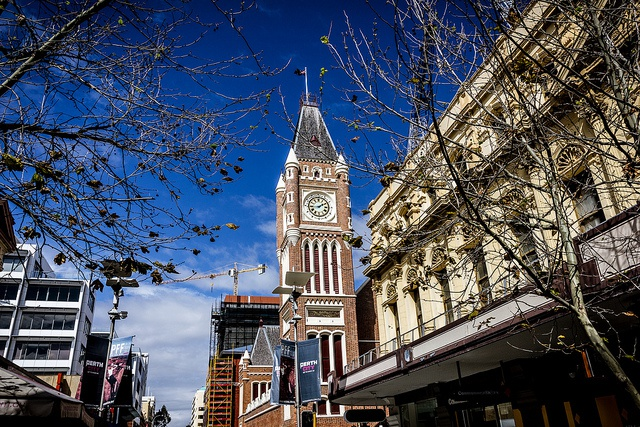Describe the objects in this image and their specific colors. I can see a clock in black, white, darkgray, and gray tones in this image. 